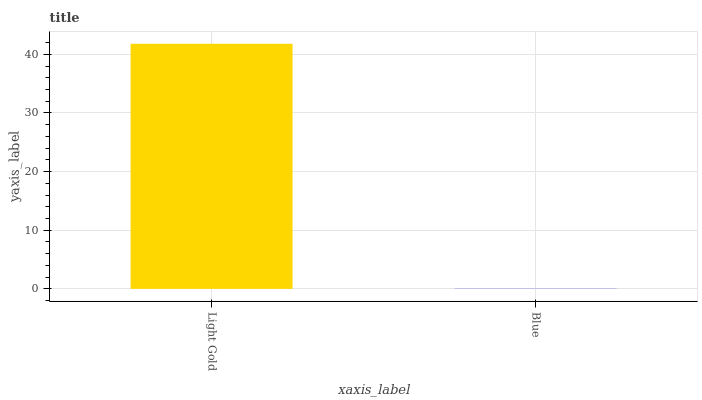Is Blue the minimum?
Answer yes or no. Yes. Is Light Gold the maximum?
Answer yes or no. Yes. Is Blue the maximum?
Answer yes or no. No. Is Light Gold greater than Blue?
Answer yes or no. Yes. Is Blue less than Light Gold?
Answer yes or no. Yes. Is Blue greater than Light Gold?
Answer yes or no. No. Is Light Gold less than Blue?
Answer yes or no. No. Is Light Gold the high median?
Answer yes or no. Yes. Is Blue the low median?
Answer yes or no. Yes. Is Blue the high median?
Answer yes or no. No. Is Light Gold the low median?
Answer yes or no. No. 